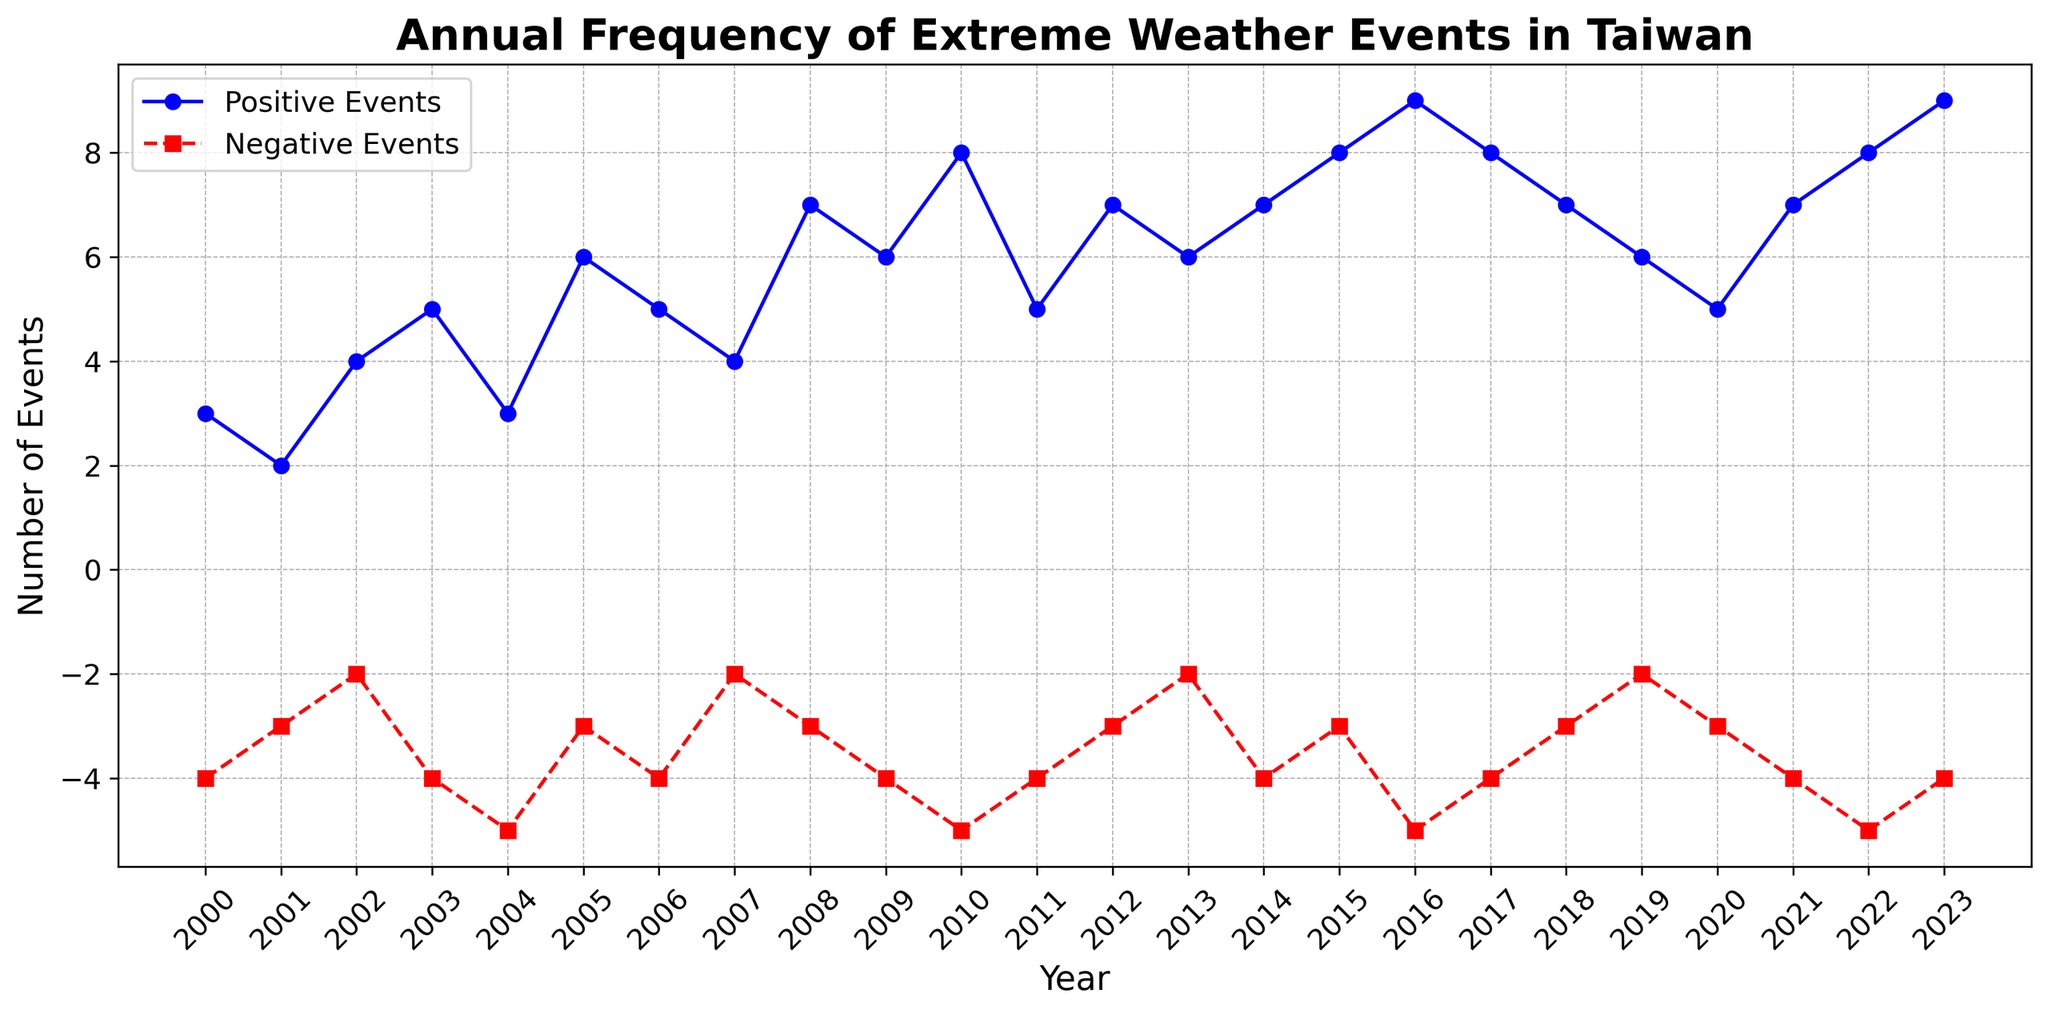What year had the highest number of positive extreme weather events? The highest number of positive extreme weather events is represented by the highest point on the blue line. In the chart, this occurs twice: in 2016 and 2023, both with 9 events.
Answer: 2016, 2023 In what year did the negative extreme weather events reach their minimum? The minimum number of negative extreme weather events is shown at the lowest point of the red dashed line. The lowest number is -5, which occurs in the years 2004, 2010, 2016, 2022.
Answer: 2004, 2010, 2016, 2022 What is the average number of positive extreme weather events from 2021 to 2023? To find the average, sum the positive events for 2021 (7), 2022 (8), and 2023 (9), then divide by the number of years (3). (7 + 8 + 9) / 3 = 8
Answer: 8 Which year saw a higher increase in positive events compared to the previous year? Calculate the difference between consecutive years' positive events: e.g., 2023 (9) - 2022 (8) = 1, 2022 (8) - 2021 (7) = 1, 2021 (7) - 2020 (5) = 2. The highest increase is from 2020 to 2021, 2 events.
Answer: 2021 Assuming a trend, do positive or negative extreme weather events increase more rapidly over the years? Observe the overall trend of the lines. The blue line for positive events shows a general upward trend, while the red dashed line for negative events shows slight variation around similar values. Positive extreme weather events increase more rapidly.
Answer: Positive events Between 2010 and 2015, how many years had more than 5 positive extreme weather events? Count the number of years within the specified range where the blue line is above 5. For 2010 (8), 2012 (7), 2013 (6), 2014 (7), 2015 (8), there are 5 such years.
Answer: 5 What is the sum of positive and negative extreme weather events in 2005? For 2005, sum the positive events (6) and negative events (-3): 6 + (-3) = 3.
Answer: 3 How many years have identical counts of negative extreme weather events? Identify repeating values along the red dashed line. The value -4 appears in the years: 2000, 2003, 2006, 2009, 2011, 2014, 2017, 2021, 2023. A total of 9 years.
Answer: 9 